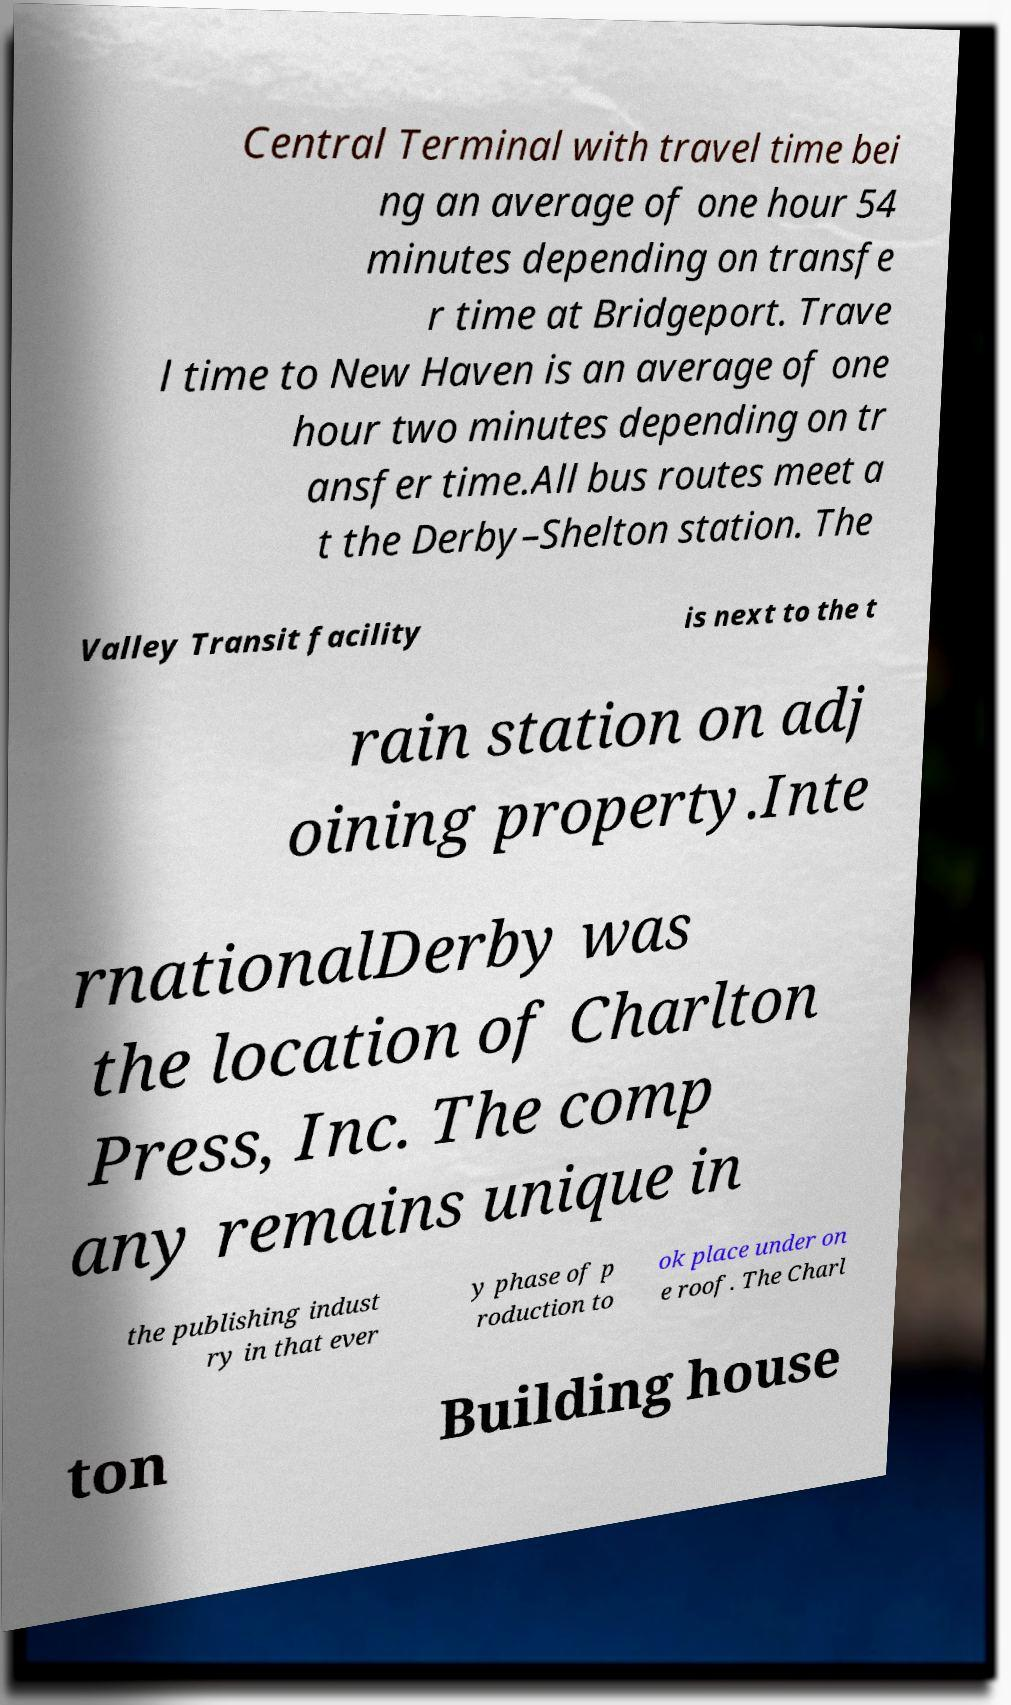Please identify and transcribe the text found in this image. Central Terminal with travel time bei ng an average of one hour 54 minutes depending on transfe r time at Bridgeport. Trave l time to New Haven is an average of one hour two minutes depending on tr ansfer time.All bus routes meet a t the Derby–Shelton station. The Valley Transit facility is next to the t rain station on adj oining property.Inte rnationalDerby was the location of Charlton Press, Inc. The comp any remains unique in the publishing indust ry in that ever y phase of p roduction to ok place under on e roof. The Charl ton Building house 